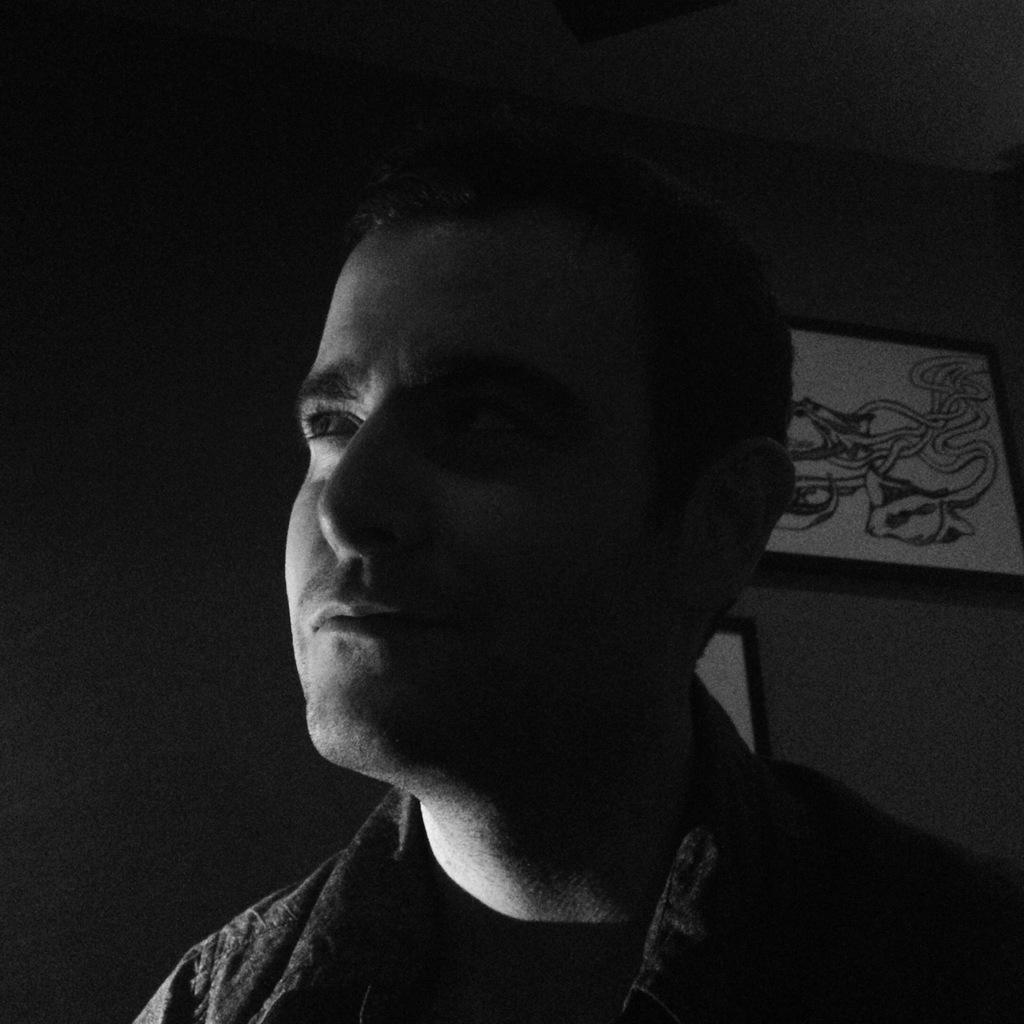Could you give a brief overview of what you see in this image? This image consists of a man. In the background, there is a wall on which frames are fixed. 